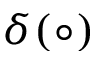<formula> <loc_0><loc_0><loc_500><loc_500>\delta ( \circ )</formula> 